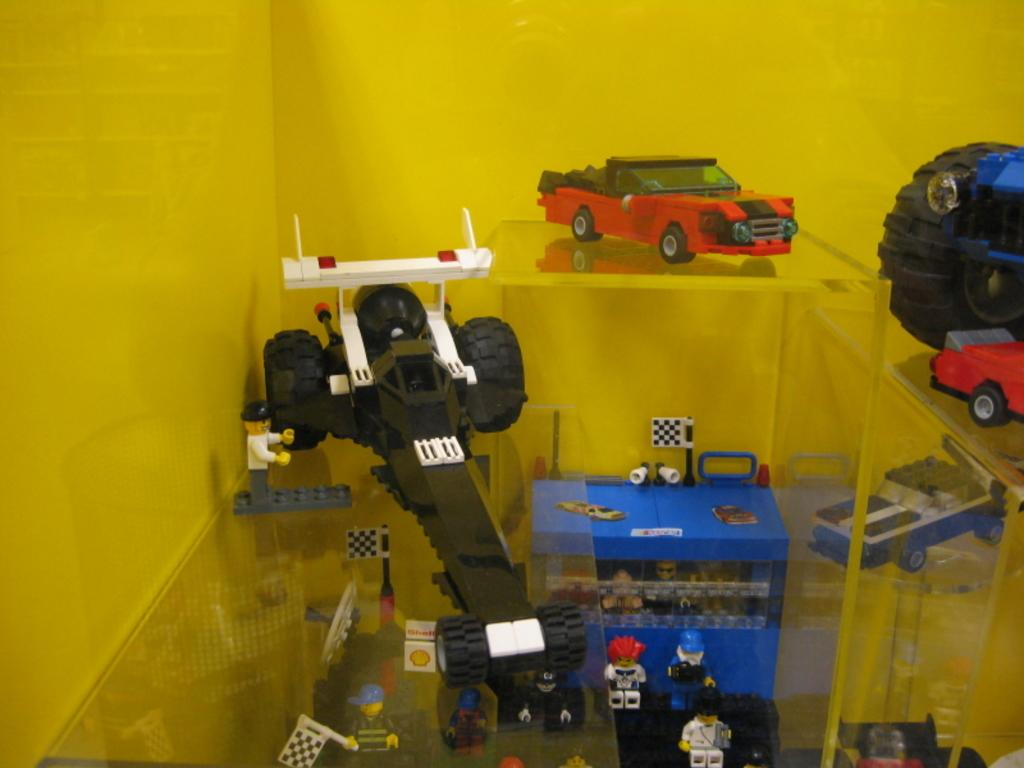What type of toys are present in the image? There are toys of cars in the image. What else can be seen in the image besides the car toys? There are other objects in the image. Where are the toys and objects located? The toys and objects are on a glass table. What can be observed in the background of the image? There is a yellow color wall in the background of the image. Can you tell me how many rabbits are playing on the page in the image? There are no rabbits or pages present in the image; it features toys of cars on a glass table with a yellow color wall in the background. 